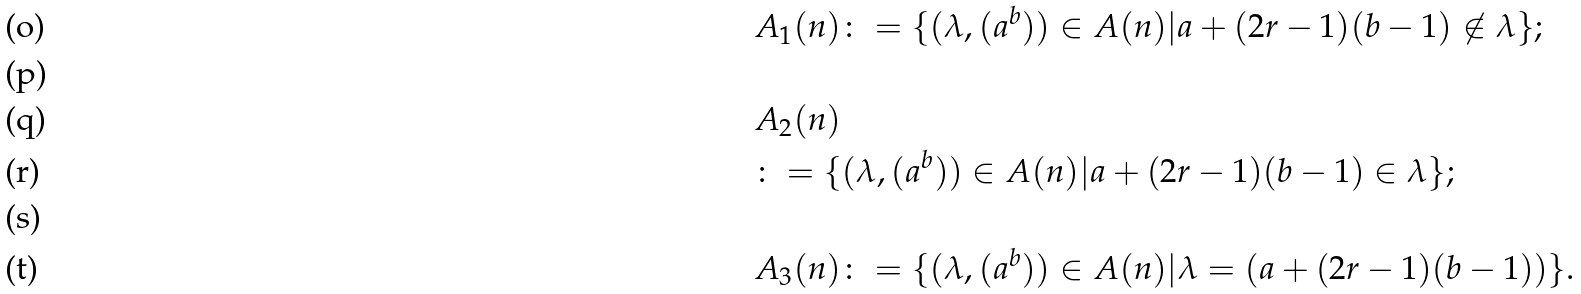Convert formula to latex. <formula><loc_0><loc_0><loc_500><loc_500>& A _ { 1 } ( n ) \colon = \{ ( \lambda , ( a ^ { b } ) ) \in A ( n ) | a + ( 2 r - 1 ) ( b - 1 ) \not \in \lambda \} ; \\ \ \\ & A _ { 2 } ( n ) \\ & \colon = { \{ ( \lambda , ( a ^ { b } ) ) \in A ( n ) | a + ( 2 r - 1 ) ( b - 1 ) \in \lambda \} ; } \\ \ \\ & A _ { 3 } ( n ) \colon = \{ ( \lambda , ( a ^ { b } ) ) \in A ( n ) | \lambda = ( a + ( 2 r - 1 ) ( b - 1 ) ) \} .</formula> 